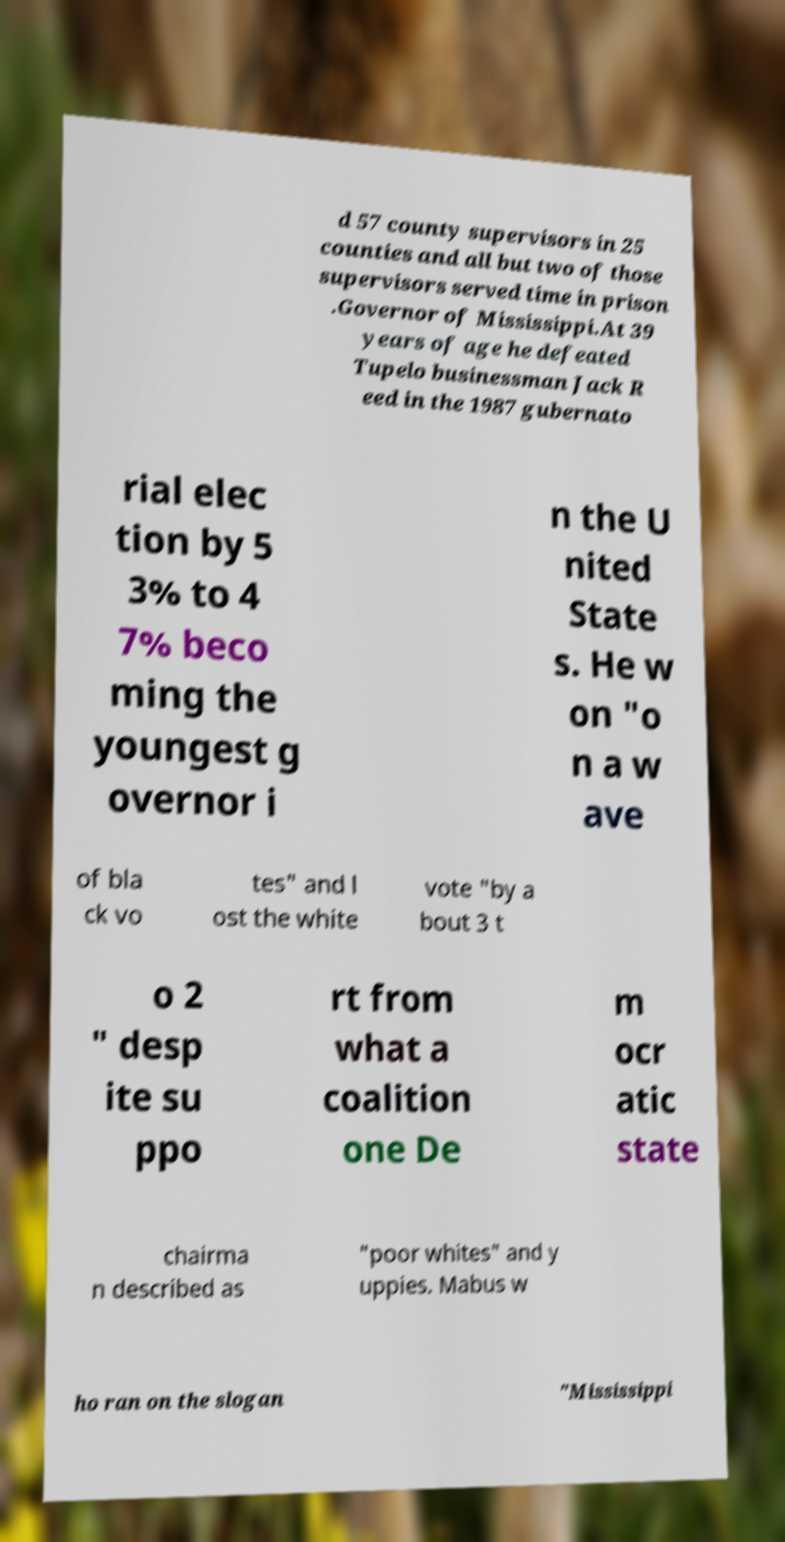There's text embedded in this image that I need extracted. Can you transcribe it verbatim? d 57 county supervisors in 25 counties and all but two of those supervisors served time in prison .Governor of Mississippi.At 39 years of age he defeated Tupelo businessman Jack R eed in the 1987 gubernato rial elec tion by 5 3% to 4 7% beco ming the youngest g overnor i n the U nited State s. He w on "o n a w ave of bla ck vo tes" and l ost the white vote "by a bout 3 t o 2 " desp ite su ppo rt from what a coalition one De m ocr atic state chairma n described as "poor whites" and y uppies. Mabus w ho ran on the slogan "Mississippi 